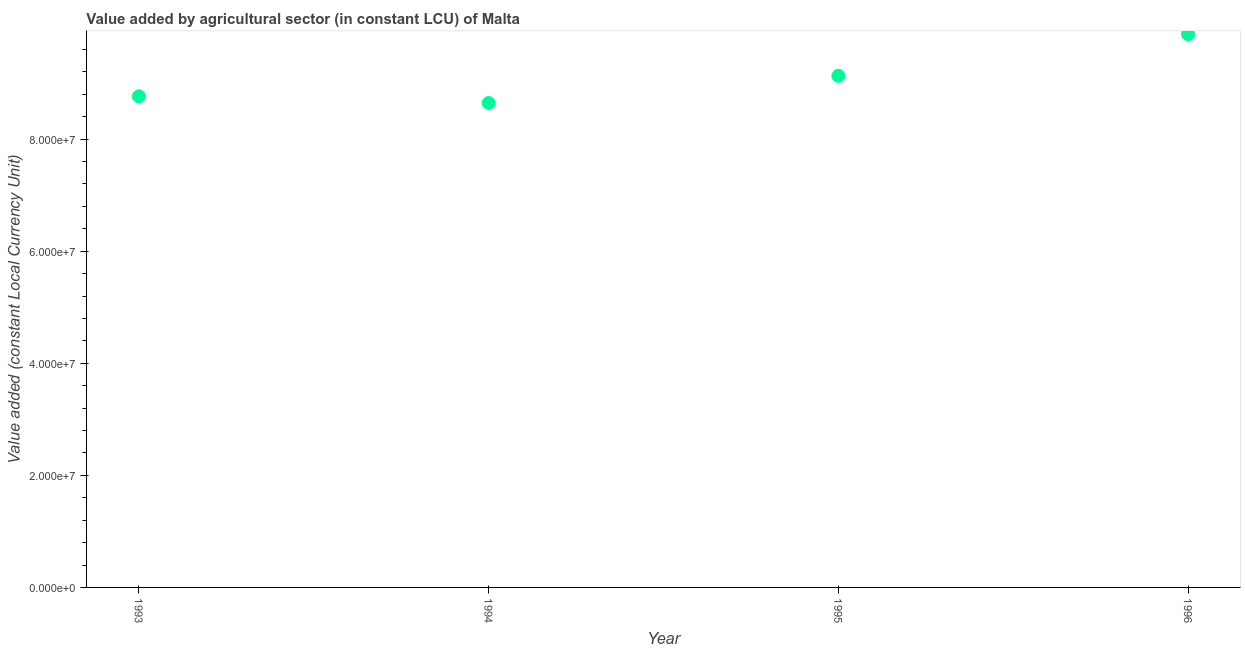What is the value added by agriculture sector in 1993?
Your answer should be compact. 8.76e+07. Across all years, what is the maximum value added by agriculture sector?
Make the answer very short. 9.87e+07. Across all years, what is the minimum value added by agriculture sector?
Provide a succinct answer. 8.64e+07. What is the sum of the value added by agriculture sector?
Give a very brief answer. 3.64e+08. What is the difference between the value added by agriculture sector in 1994 and 1995?
Provide a succinct answer. -4.85e+06. What is the average value added by agriculture sector per year?
Provide a succinct answer. 9.10e+07. What is the median value added by agriculture sector?
Offer a terse response. 8.95e+07. In how many years, is the value added by agriculture sector greater than 48000000 LCU?
Make the answer very short. 4. Do a majority of the years between 1995 and 1993 (inclusive) have value added by agriculture sector greater than 92000000 LCU?
Keep it short and to the point. No. What is the ratio of the value added by agriculture sector in 1994 to that in 1995?
Make the answer very short. 0.95. Is the value added by agriculture sector in 1993 less than that in 1994?
Provide a succinct answer. No. Is the difference between the value added by agriculture sector in 1993 and 1995 greater than the difference between any two years?
Offer a very short reply. No. What is the difference between the highest and the second highest value added by agriculture sector?
Keep it short and to the point. 7.41e+06. Is the sum of the value added by agriculture sector in 1993 and 1995 greater than the maximum value added by agriculture sector across all years?
Provide a succinct answer. Yes. What is the difference between the highest and the lowest value added by agriculture sector?
Your answer should be compact. 1.23e+07. In how many years, is the value added by agriculture sector greater than the average value added by agriculture sector taken over all years?
Give a very brief answer. 2. Does the value added by agriculture sector monotonically increase over the years?
Give a very brief answer. No. How many dotlines are there?
Provide a short and direct response. 1. How many years are there in the graph?
Provide a short and direct response. 4. What is the difference between two consecutive major ticks on the Y-axis?
Give a very brief answer. 2.00e+07. Are the values on the major ticks of Y-axis written in scientific E-notation?
Your response must be concise. Yes. Does the graph contain any zero values?
Your answer should be very brief. No. Does the graph contain grids?
Make the answer very short. No. What is the title of the graph?
Provide a short and direct response. Value added by agricultural sector (in constant LCU) of Malta. What is the label or title of the X-axis?
Provide a succinct answer. Year. What is the label or title of the Y-axis?
Ensure brevity in your answer.  Value added (constant Local Currency Unit). What is the Value added (constant Local Currency Unit) in 1993?
Ensure brevity in your answer.  8.76e+07. What is the Value added (constant Local Currency Unit) in 1994?
Provide a short and direct response. 8.64e+07. What is the Value added (constant Local Currency Unit) in 1995?
Your answer should be very brief. 9.13e+07. What is the Value added (constant Local Currency Unit) in 1996?
Ensure brevity in your answer.  9.87e+07. What is the difference between the Value added (constant Local Currency Unit) in 1993 and 1994?
Your answer should be very brief. 1.19e+06. What is the difference between the Value added (constant Local Currency Unit) in 1993 and 1995?
Provide a short and direct response. -3.67e+06. What is the difference between the Value added (constant Local Currency Unit) in 1993 and 1996?
Provide a short and direct response. -1.11e+07. What is the difference between the Value added (constant Local Currency Unit) in 1994 and 1995?
Offer a very short reply. -4.85e+06. What is the difference between the Value added (constant Local Currency Unit) in 1994 and 1996?
Ensure brevity in your answer.  -1.23e+07. What is the difference between the Value added (constant Local Currency Unit) in 1995 and 1996?
Make the answer very short. -7.41e+06. What is the ratio of the Value added (constant Local Currency Unit) in 1993 to that in 1996?
Provide a short and direct response. 0.89. What is the ratio of the Value added (constant Local Currency Unit) in 1994 to that in 1995?
Offer a terse response. 0.95. What is the ratio of the Value added (constant Local Currency Unit) in 1994 to that in 1996?
Provide a succinct answer. 0.88. What is the ratio of the Value added (constant Local Currency Unit) in 1995 to that in 1996?
Make the answer very short. 0.93. 